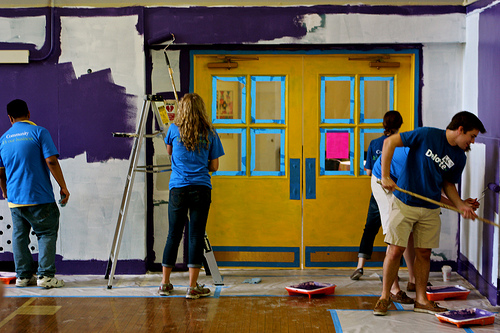<image>
Can you confirm if the tape is on the floor? Yes. Looking at the image, I can see the tape is positioned on top of the floor, with the floor providing support. Where is the girl in relation to the boy? Is it on the boy? No. The girl is not positioned on the boy. They may be near each other, but the girl is not supported by or resting on top of the boy. Is the ladder behind the girl? Yes. From this viewpoint, the ladder is positioned behind the girl, with the girl partially or fully occluding the ladder. 